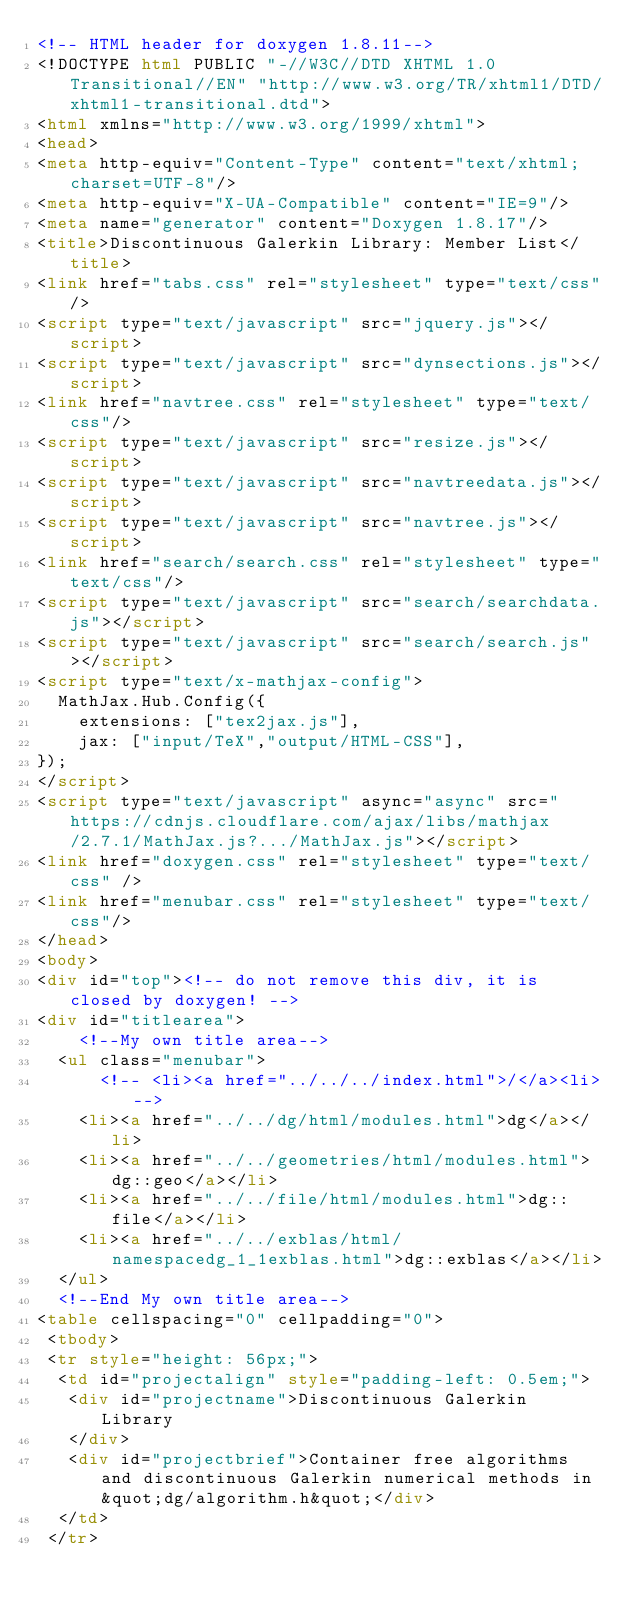Convert code to text. <code><loc_0><loc_0><loc_500><loc_500><_HTML_><!-- HTML header for doxygen 1.8.11-->
<!DOCTYPE html PUBLIC "-//W3C//DTD XHTML 1.0 Transitional//EN" "http://www.w3.org/TR/xhtml1/DTD/xhtml1-transitional.dtd">
<html xmlns="http://www.w3.org/1999/xhtml">
<head>
<meta http-equiv="Content-Type" content="text/xhtml;charset=UTF-8"/>
<meta http-equiv="X-UA-Compatible" content="IE=9"/>
<meta name="generator" content="Doxygen 1.8.17"/>
<title>Discontinuous Galerkin Library: Member List</title>
<link href="tabs.css" rel="stylesheet" type="text/css"/>
<script type="text/javascript" src="jquery.js"></script>
<script type="text/javascript" src="dynsections.js"></script>
<link href="navtree.css" rel="stylesheet" type="text/css"/>
<script type="text/javascript" src="resize.js"></script>
<script type="text/javascript" src="navtreedata.js"></script>
<script type="text/javascript" src="navtree.js"></script>
<link href="search/search.css" rel="stylesheet" type="text/css"/>
<script type="text/javascript" src="search/searchdata.js"></script>
<script type="text/javascript" src="search/search.js"></script>
<script type="text/x-mathjax-config">
  MathJax.Hub.Config({
    extensions: ["tex2jax.js"],
    jax: ["input/TeX","output/HTML-CSS"],
});
</script>
<script type="text/javascript" async="async" src="https://cdnjs.cloudflare.com/ajax/libs/mathjax/2.7.1/MathJax.js?.../MathJax.js"></script>
<link href="doxygen.css" rel="stylesheet" type="text/css" />
<link href="menubar.css" rel="stylesheet" type="text/css"/>
</head>
<body>
<div id="top"><!-- do not remove this div, it is closed by doxygen! -->
<div id="titlearea">
    <!--My own title area-->
  <ul class="menubar">
      <!-- <li><a href="../../../index.html">/</a><li>-->
    <li><a href="../../dg/html/modules.html">dg</a></li>
    <li><a href="../../geometries/html/modules.html">dg::geo</a></li>
    <li><a href="../../file/html/modules.html">dg::file</a></li>
    <li><a href="../../exblas/html/namespacedg_1_1exblas.html">dg::exblas</a></li>
  </ul>
  <!--End My own title area-->
<table cellspacing="0" cellpadding="0">
 <tbody>
 <tr style="height: 56px;">
  <td id="projectalign" style="padding-left: 0.5em;">
   <div id="projectname">Discontinuous Galerkin Library
   </div>
   <div id="projectbrief">Container free algorithms and discontinuous Galerkin numerical methods in &quot;dg/algorithm.h&quot;</div>
  </td>
 </tr></code> 